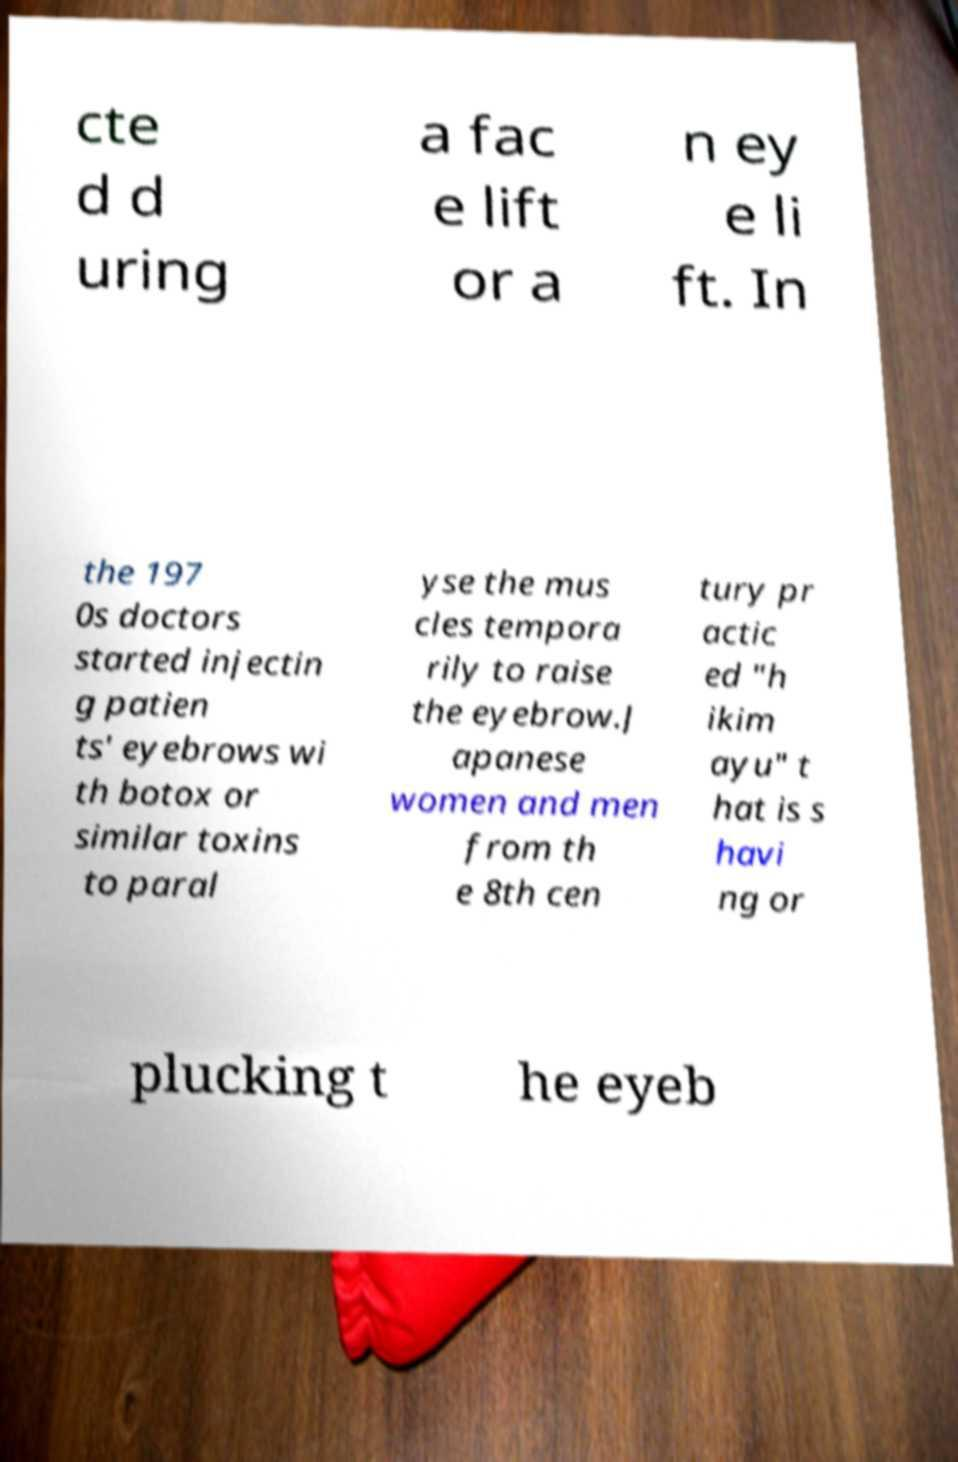There's text embedded in this image that I need extracted. Can you transcribe it verbatim? cte d d uring a fac e lift or a n ey e li ft. In the 197 0s doctors started injectin g patien ts' eyebrows wi th botox or similar toxins to paral yse the mus cles tempora rily to raise the eyebrow.J apanese women and men from th e 8th cen tury pr actic ed "h ikim ayu" t hat is s havi ng or plucking t he eyeb 